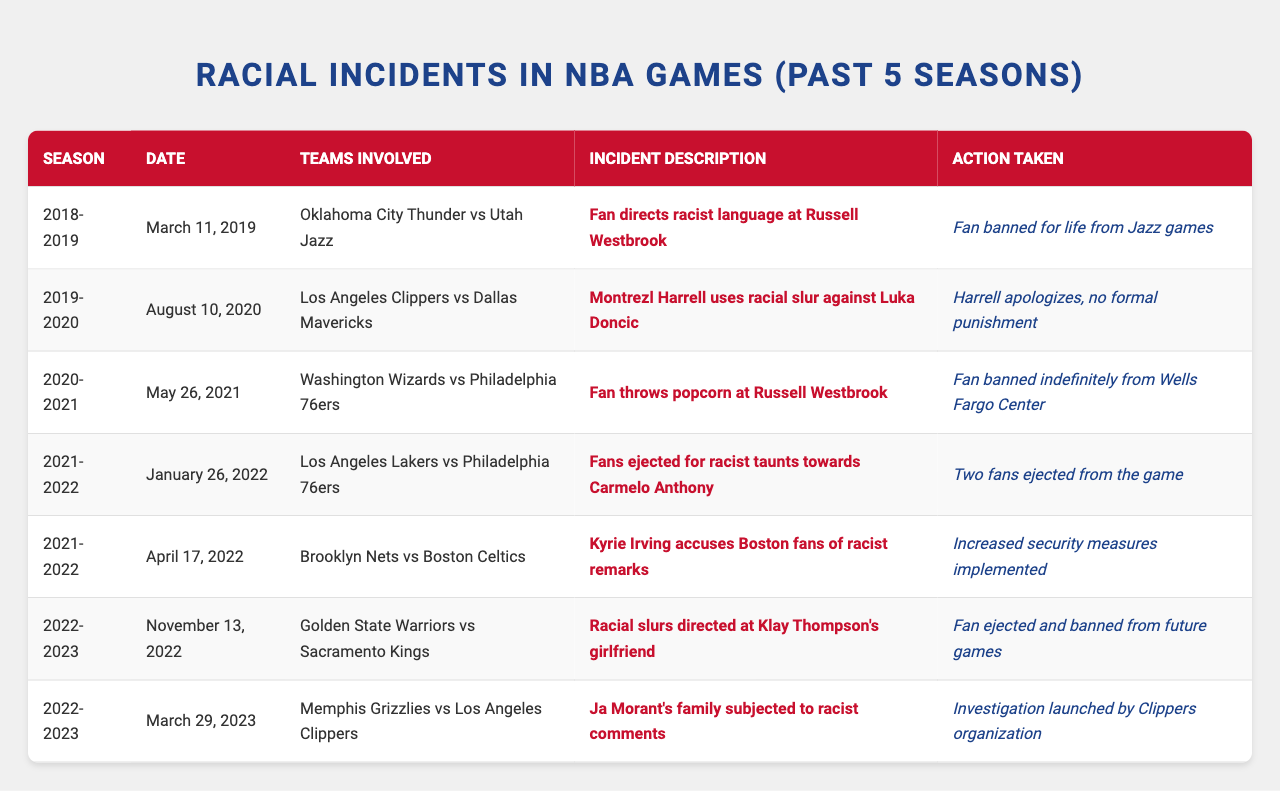What incident involved Russell Westbrook and the Oklahoma City Thunder? The table lists an incident on March 11, 2019, where a fan directed racist language at Russell Westbrook during a game between the Oklahoma City Thunder and Utah Jazz.
Answer: A fan directed racist language at Russell Westbrook How many incidents resulted in fans being banned? By reviewing the table, we can count the incidents where fans were banned: there are four instances. This includes the fan banned for life from Jazz games, the fan banned indefinitely from Wells Fargo Center, and the fan ejected and banned from future games.
Answer: Four incidents Which season had the highest number of racial incidents listed? By examining the data, we find incidents for the following seasons: 2018-2019 (1 incident), 2019-2020 (1 incident), 2020-2021 (1 incident), 2021-2022 (2 incidents), and 2022-2023 (2 incidents). The seasons with the most incidents are 2021-2022 and 2022-2023.
Answer: 2021-2022 and 2022-2023 Was there any formal punishment for Montrezl Harrell after his incident? The table states that Montrezl Harrell apologized but faced no formal punishment after using a racial slur against Luka Doncic.
Answer: No What actions were taken after Kyrie Irving accused Boston fans of racist remarks? According to the table, after Kyrie Irving's accusations against Boston fans, increased security measures were implemented during the Brooklyn Nets vs. Boston Celtics game on April 17, 2022.
Answer: Increased security measures were implemented How many incidents involved Russell Westbrook, and what actions were taken in those cases? The table indicates that there were two incidents involving Russell Westbrook. In the first case, on March 11, 2019, a fan was banned for life, and in the second case, on May 26, 2021, a fan was banned indefinitely.
Answer: Two incidents; actions taken were bans Which teams were involved in the incident where Ja Morant’s family faced racist comments? The incident occurred on March 29, 2023, involving the Memphis Grizzlies and Los Angeles Clippers.
Answer: Memphis Grizzlies and Los Angeles Clippers Were there any incidents where fans were ejected during the 2021-2022 season? Yes, the table shows an incident on January 26, 2022, where fans were ejected for racist taunts towards Carmelo Anthony during a game between the Los Angeles Lakers and Philadelphia 76ers.
Answer: Yes What incident was reported during the 2019-2020 season? The table lists the incident on August 10, 2020, where Montrezl Harrell used a racial slur against Luka Doncic in a game between the Los Angeles Clippers and Dallas Mavericks.
Answer: Montrezl Harrell used a racial slur against Luka Doncic How many incidents were recorded in 2022? In 2022, there were three incidents recorded: one in January and two in April, making the total equal to three.
Answer: Three incidents 